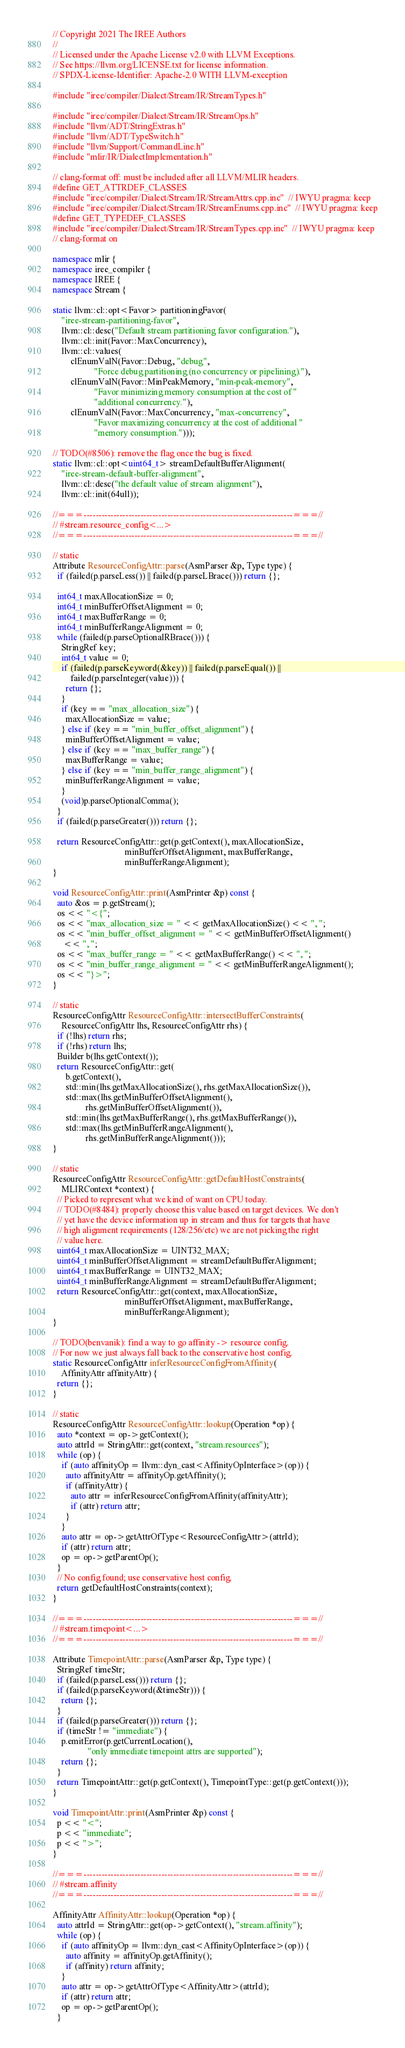<code> <loc_0><loc_0><loc_500><loc_500><_C++_>// Copyright 2021 The IREE Authors
//
// Licensed under the Apache License v2.0 with LLVM Exceptions.
// See https://llvm.org/LICENSE.txt for license information.
// SPDX-License-Identifier: Apache-2.0 WITH LLVM-exception

#include "iree/compiler/Dialect/Stream/IR/StreamTypes.h"

#include "iree/compiler/Dialect/Stream/IR/StreamOps.h"
#include "llvm/ADT/StringExtras.h"
#include "llvm/ADT/TypeSwitch.h"
#include "llvm/Support/CommandLine.h"
#include "mlir/IR/DialectImplementation.h"

// clang-format off: must be included after all LLVM/MLIR headers.
#define GET_ATTRDEF_CLASSES
#include "iree/compiler/Dialect/Stream/IR/StreamAttrs.cpp.inc"  // IWYU pragma: keep
#include "iree/compiler/Dialect/Stream/IR/StreamEnums.cpp.inc"  // IWYU pragma: keep
#define GET_TYPEDEF_CLASSES
#include "iree/compiler/Dialect/Stream/IR/StreamTypes.cpp.inc"  // IWYU pragma: keep
// clang-format on

namespace mlir {
namespace iree_compiler {
namespace IREE {
namespace Stream {

static llvm::cl::opt<Favor> partitioningFavor(
    "iree-stream-partitioning-favor",
    llvm::cl::desc("Default stream partitioning favor configuration."),
    llvm::cl::init(Favor::MaxConcurrency),
    llvm::cl::values(
        clEnumValN(Favor::Debug, "debug",
                   "Force debug partitioning (no concurrency or pipelining)."),
        clEnumValN(Favor::MinPeakMemory, "min-peak-memory",
                   "Favor minimizing memory consumption at the cost of "
                   "additional concurrency."),
        clEnumValN(Favor::MaxConcurrency, "max-concurrency",
                   "Favor maximizing concurrency at the cost of additional "
                   "memory consumption.")));

// TODO(#8506): remove the flag once the bug is fixed.
static llvm::cl::opt<uint64_t> streamDefaultBufferAlignment(
    "iree-stream-default-buffer-alignment",
    llvm::cl::desc("the default value of stream alignment"),
    llvm::cl::init(64ull));

//===----------------------------------------------------------------------===//
// #stream.resource_config<...>
//===----------------------------------------------------------------------===//

// static
Attribute ResourceConfigAttr::parse(AsmParser &p, Type type) {
  if (failed(p.parseLess()) || failed(p.parseLBrace())) return {};

  int64_t maxAllocationSize = 0;
  int64_t minBufferOffsetAlignment = 0;
  int64_t maxBufferRange = 0;
  int64_t minBufferRangeAlignment = 0;
  while (failed(p.parseOptionalRBrace())) {
    StringRef key;
    int64_t value = 0;
    if (failed(p.parseKeyword(&key)) || failed(p.parseEqual()) ||
        failed(p.parseInteger(value))) {
      return {};
    }
    if (key == "max_allocation_size") {
      maxAllocationSize = value;
    } else if (key == "min_buffer_offset_alignment") {
      minBufferOffsetAlignment = value;
    } else if (key == "max_buffer_range") {
      maxBufferRange = value;
    } else if (key == "min_buffer_range_alignment") {
      minBufferRangeAlignment = value;
    }
    (void)p.parseOptionalComma();
  }
  if (failed(p.parseGreater())) return {};

  return ResourceConfigAttr::get(p.getContext(), maxAllocationSize,
                                 minBufferOffsetAlignment, maxBufferRange,
                                 minBufferRangeAlignment);
}

void ResourceConfigAttr::print(AsmPrinter &p) const {
  auto &os = p.getStream();
  os << "<{";
  os << "max_allocation_size = " << getMaxAllocationSize() << ", ";
  os << "min_buffer_offset_alignment = " << getMinBufferOffsetAlignment()
     << ", ";
  os << "max_buffer_range = " << getMaxBufferRange() << ", ";
  os << "min_buffer_range_alignment = " << getMinBufferRangeAlignment();
  os << "}>";
}

// static
ResourceConfigAttr ResourceConfigAttr::intersectBufferConstraints(
    ResourceConfigAttr lhs, ResourceConfigAttr rhs) {
  if (!lhs) return rhs;
  if (!rhs) return lhs;
  Builder b(lhs.getContext());
  return ResourceConfigAttr::get(
      b.getContext(),
      std::min(lhs.getMaxAllocationSize(), rhs.getMaxAllocationSize()),
      std::max(lhs.getMinBufferOffsetAlignment(),
               rhs.getMinBufferOffsetAlignment()),
      std::min(lhs.getMaxBufferRange(), rhs.getMaxBufferRange()),
      std::max(lhs.getMinBufferRangeAlignment(),
               rhs.getMinBufferRangeAlignment()));
}

// static
ResourceConfigAttr ResourceConfigAttr::getDefaultHostConstraints(
    MLIRContext *context) {
  // Picked to represent what we kind of want on CPU today.
  // TODO(#8484): properly choose this value based on target devices. We don't
  // yet have the device information up in stream and thus for targets that have
  // high alignment requirements (128/256/etc) we are not picking the right
  // value here.
  uint64_t maxAllocationSize = UINT32_MAX;
  uint64_t minBufferOffsetAlignment = streamDefaultBufferAlignment;
  uint64_t maxBufferRange = UINT32_MAX;
  uint64_t minBufferRangeAlignment = streamDefaultBufferAlignment;
  return ResourceConfigAttr::get(context, maxAllocationSize,
                                 minBufferOffsetAlignment, maxBufferRange,
                                 minBufferRangeAlignment);
}

// TODO(benvanik): find a way to go affinity -> resource config.
// For now we just always fall back to the conservative host config.
static ResourceConfigAttr inferResourceConfigFromAffinity(
    AffinityAttr affinityAttr) {
  return {};
}

// static
ResourceConfigAttr ResourceConfigAttr::lookup(Operation *op) {
  auto *context = op->getContext();
  auto attrId = StringAttr::get(context, "stream.resources");
  while (op) {
    if (auto affinityOp = llvm::dyn_cast<AffinityOpInterface>(op)) {
      auto affinityAttr = affinityOp.getAffinity();
      if (affinityAttr) {
        auto attr = inferResourceConfigFromAffinity(affinityAttr);
        if (attr) return attr;
      }
    }
    auto attr = op->getAttrOfType<ResourceConfigAttr>(attrId);
    if (attr) return attr;
    op = op->getParentOp();
  }
  // No config found; use conservative host config.
  return getDefaultHostConstraints(context);
}

//===----------------------------------------------------------------------===//
// #stream.timepoint<...>
//===----------------------------------------------------------------------===//

Attribute TimepointAttr::parse(AsmParser &p, Type type) {
  StringRef timeStr;
  if (failed(p.parseLess())) return {};
  if (failed(p.parseKeyword(&timeStr))) {
    return {};
  }
  if (failed(p.parseGreater())) return {};
  if (timeStr != "immediate") {
    p.emitError(p.getCurrentLocation(),
                "only immediate timepoint attrs are supported");
    return {};
  }
  return TimepointAttr::get(p.getContext(), TimepointType::get(p.getContext()));
}

void TimepointAttr::print(AsmPrinter &p) const {
  p << "<";
  p << "immediate";
  p << ">";
}

//===----------------------------------------------------------------------===//
// #stream.affinity
//===----------------------------------------------------------------------===//

AffinityAttr AffinityAttr::lookup(Operation *op) {
  auto attrId = StringAttr::get(op->getContext(), "stream.affinity");
  while (op) {
    if (auto affinityOp = llvm::dyn_cast<AffinityOpInterface>(op)) {
      auto affinity = affinityOp.getAffinity();
      if (affinity) return affinity;
    }
    auto attr = op->getAttrOfType<AffinityAttr>(attrId);
    if (attr) return attr;
    op = op->getParentOp();
  }</code> 